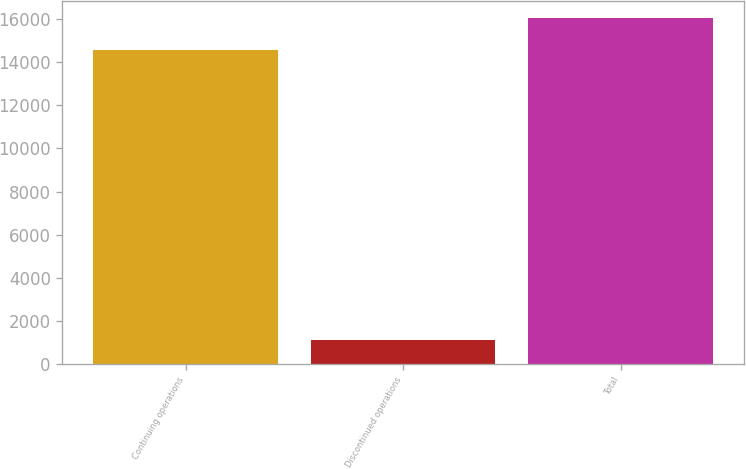Convert chart. <chart><loc_0><loc_0><loc_500><loc_500><bar_chart><fcel>Continuing operations<fcel>Discontinued operations<fcel>Total<nl><fcel>14592<fcel>1098<fcel>16051.2<nl></chart> 